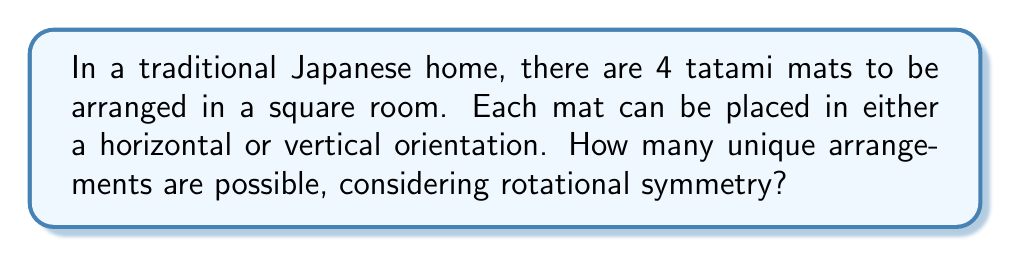Show me your answer to this math problem. Let's approach this step-by-step:

1) First, we need to understand that each mat has two possible orientations: horizontal or vertical.

2) With 4 mats, we initially have $2^4 = 16$ possible arrangements.

3) However, we need to consider rotational symmetry. In a square room, rotations of 90°, 180°, and 270° will produce arrangements that are considered identical.

4) To account for this, we need to divide our total arrangements by 4 (the number of rotational symmetries in a square).

5) However, some arrangements might be symmetric under rotation, and dividing by 4 would undercount these. We need to carefully count these special cases:

   a) All mats horizontal or all vertical: 2 arrangements
   b) Two horizontal and two vertical in alternating pattern: 1 arrangement

6) These 3 arrangements are invariant under rotation and should be counted only once.

7) For the remaining arrangements:
   $\frac{16 - 3}{4} = \frac{13}{4} = 3.25$

8) Since we can't have a fractional number of arrangements, we round this up to 4.

9) Finally, we add back the 3 special cases:
   $4 + 3 = 7$

Therefore, there are 7 unique arrangements possible.
Answer: 7 